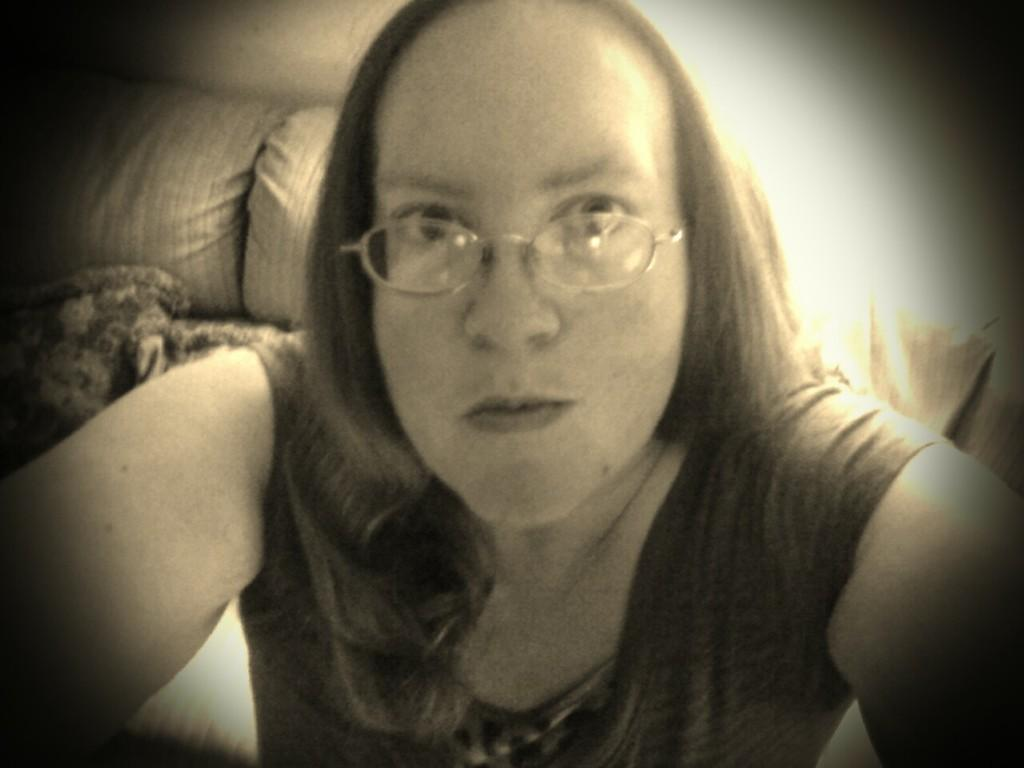Who is responsible for capturing the image? There is a person taking the picture. What can be seen in the background of the image? There is a sofa in the background of the image. How many men are planting seeds in the cabbage patch in the image? There is no cabbage patch or men planting seeds in the image. 